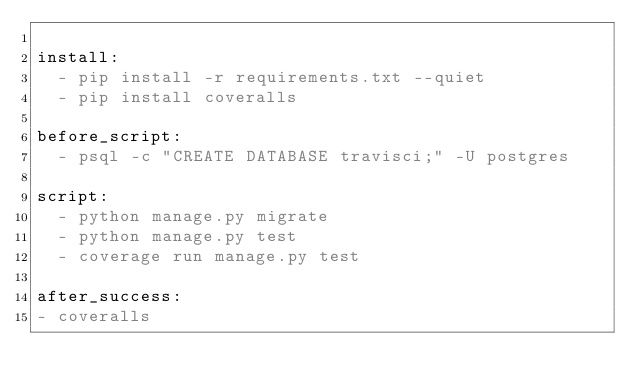Convert code to text. <code><loc_0><loc_0><loc_500><loc_500><_YAML_>
install:
  - pip install -r requirements.txt --quiet
  - pip install coveralls

before_script:
  - psql -c "CREATE DATABASE travisci;" -U postgres

script:
  - python manage.py migrate
  - python manage.py test
  - coverage run manage.py test

after_success:
- coveralls</code> 